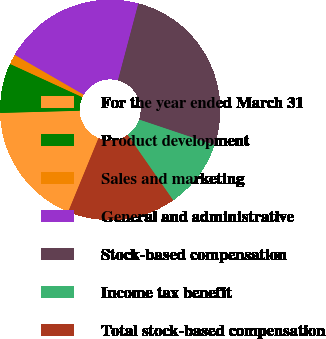Convert chart to OTSL. <chart><loc_0><loc_0><loc_500><loc_500><pie_chart><fcel>For the year ended March 31<fcel>Product development<fcel>Sales and marketing<fcel>General and administrative<fcel>Stock-based compensation<fcel>Income tax benefit<fcel>Total stock-based compensation<nl><fcel>18.35%<fcel>7.3%<fcel>1.47%<fcel>20.8%<fcel>26.04%<fcel>10.15%<fcel>15.89%<nl></chart> 